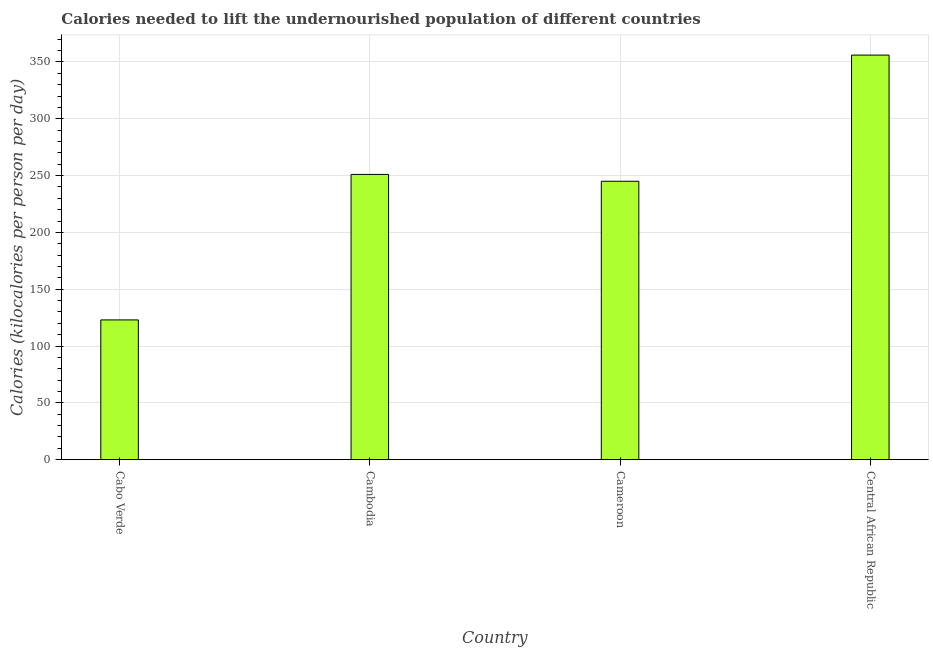Does the graph contain any zero values?
Your response must be concise. No. What is the title of the graph?
Offer a very short reply. Calories needed to lift the undernourished population of different countries. What is the label or title of the X-axis?
Your response must be concise. Country. What is the label or title of the Y-axis?
Your response must be concise. Calories (kilocalories per person per day). What is the depth of food deficit in Cameroon?
Provide a succinct answer. 245. Across all countries, what is the maximum depth of food deficit?
Give a very brief answer. 356. Across all countries, what is the minimum depth of food deficit?
Ensure brevity in your answer.  123. In which country was the depth of food deficit maximum?
Ensure brevity in your answer.  Central African Republic. In which country was the depth of food deficit minimum?
Your response must be concise. Cabo Verde. What is the sum of the depth of food deficit?
Offer a very short reply. 975. What is the difference between the depth of food deficit in Cabo Verde and Cambodia?
Your answer should be very brief. -128. What is the average depth of food deficit per country?
Offer a very short reply. 243.75. What is the median depth of food deficit?
Offer a terse response. 248. In how many countries, is the depth of food deficit greater than 150 kilocalories?
Ensure brevity in your answer.  3. What is the ratio of the depth of food deficit in Cabo Verde to that in Central African Republic?
Offer a terse response. 0.35. What is the difference between the highest and the second highest depth of food deficit?
Offer a terse response. 105. Is the sum of the depth of food deficit in Cambodia and Central African Republic greater than the maximum depth of food deficit across all countries?
Keep it short and to the point. Yes. What is the difference between the highest and the lowest depth of food deficit?
Your response must be concise. 233. How many bars are there?
Your response must be concise. 4. What is the difference between two consecutive major ticks on the Y-axis?
Offer a very short reply. 50. Are the values on the major ticks of Y-axis written in scientific E-notation?
Make the answer very short. No. What is the Calories (kilocalories per person per day) in Cabo Verde?
Your answer should be very brief. 123. What is the Calories (kilocalories per person per day) of Cambodia?
Ensure brevity in your answer.  251. What is the Calories (kilocalories per person per day) in Cameroon?
Your response must be concise. 245. What is the Calories (kilocalories per person per day) of Central African Republic?
Give a very brief answer. 356. What is the difference between the Calories (kilocalories per person per day) in Cabo Verde and Cambodia?
Give a very brief answer. -128. What is the difference between the Calories (kilocalories per person per day) in Cabo Verde and Cameroon?
Give a very brief answer. -122. What is the difference between the Calories (kilocalories per person per day) in Cabo Verde and Central African Republic?
Your answer should be compact. -233. What is the difference between the Calories (kilocalories per person per day) in Cambodia and Central African Republic?
Your response must be concise. -105. What is the difference between the Calories (kilocalories per person per day) in Cameroon and Central African Republic?
Provide a succinct answer. -111. What is the ratio of the Calories (kilocalories per person per day) in Cabo Verde to that in Cambodia?
Provide a succinct answer. 0.49. What is the ratio of the Calories (kilocalories per person per day) in Cabo Verde to that in Cameroon?
Keep it short and to the point. 0.5. What is the ratio of the Calories (kilocalories per person per day) in Cabo Verde to that in Central African Republic?
Give a very brief answer. 0.35. What is the ratio of the Calories (kilocalories per person per day) in Cambodia to that in Cameroon?
Keep it short and to the point. 1.02. What is the ratio of the Calories (kilocalories per person per day) in Cambodia to that in Central African Republic?
Your response must be concise. 0.7. What is the ratio of the Calories (kilocalories per person per day) in Cameroon to that in Central African Republic?
Give a very brief answer. 0.69. 